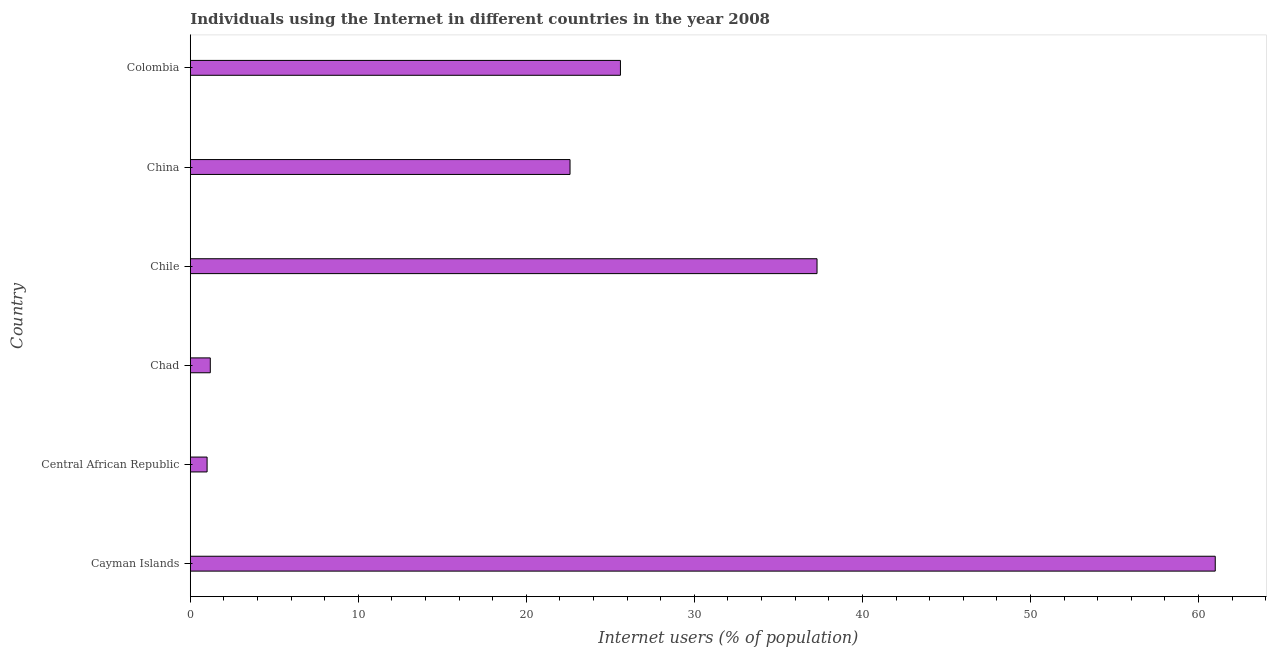Does the graph contain any zero values?
Keep it short and to the point. No. What is the title of the graph?
Ensure brevity in your answer.  Individuals using the Internet in different countries in the year 2008. What is the label or title of the X-axis?
Give a very brief answer. Internet users (% of population). In which country was the number of internet users maximum?
Provide a short and direct response. Cayman Islands. In which country was the number of internet users minimum?
Provide a short and direct response. Central African Republic. What is the sum of the number of internet users?
Your answer should be very brief. 148.69. What is the difference between the number of internet users in Chad and Chile?
Your answer should be compact. -36.11. What is the average number of internet users per country?
Your response must be concise. 24.78. What is the median number of internet users?
Your response must be concise. 24.1. In how many countries, is the number of internet users greater than 56 %?
Provide a succinct answer. 1. What is the ratio of the number of internet users in China to that in Colombia?
Your response must be concise. 0.88. Is the difference between the number of internet users in Central African Republic and China greater than the difference between any two countries?
Provide a short and direct response. No. What is the difference between the highest and the second highest number of internet users?
Keep it short and to the point. 23.7. Is the sum of the number of internet users in China and Colombia greater than the maximum number of internet users across all countries?
Your answer should be compact. No. What is the difference between the highest and the lowest number of internet users?
Give a very brief answer. 60. In how many countries, is the number of internet users greater than the average number of internet users taken over all countries?
Your answer should be very brief. 3. How many bars are there?
Keep it short and to the point. 6. Are all the bars in the graph horizontal?
Provide a short and direct response. Yes. How many countries are there in the graph?
Provide a succinct answer. 6. What is the difference between two consecutive major ticks on the X-axis?
Offer a very short reply. 10. What is the Internet users (% of population) of Central African Republic?
Your answer should be very brief. 1. What is the Internet users (% of population) in Chad?
Provide a succinct answer. 1.19. What is the Internet users (% of population) in Chile?
Give a very brief answer. 37.3. What is the Internet users (% of population) in China?
Your answer should be very brief. 22.6. What is the Internet users (% of population) of Colombia?
Ensure brevity in your answer.  25.6. What is the difference between the Internet users (% of population) in Cayman Islands and Chad?
Offer a very short reply. 59.81. What is the difference between the Internet users (% of population) in Cayman Islands and Chile?
Offer a terse response. 23.7. What is the difference between the Internet users (% of population) in Cayman Islands and China?
Offer a very short reply. 38.4. What is the difference between the Internet users (% of population) in Cayman Islands and Colombia?
Ensure brevity in your answer.  35.4. What is the difference between the Internet users (% of population) in Central African Republic and Chad?
Provide a succinct answer. -0.19. What is the difference between the Internet users (% of population) in Central African Republic and Chile?
Your answer should be very brief. -36.3. What is the difference between the Internet users (% of population) in Central African Republic and China?
Provide a succinct answer. -21.6. What is the difference between the Internet users (% of population) in Central African Republic and Colombia?
Keep it short and to the point. -24.6. What is the difference between the Internet users (% of population) in Chad and Chile?
Offer a terse response. -36.11. What is the difference between the Internet users (% of population) in Chad and China?
Offer a terse response. -21.41. What is the difference between the Internet users (% of population) in Chad and Colombia?
Keep it short and to the point. -24.41. What is the difference between the Internet users (% of population) in Chile and Colombia?
Make the answer very short. 11.7. What is the difference between the Internet users (% of population) in China and Colombia?
Ensure brevity in your answer.  -3. What is the ratio of the Internet users (% of population) in Cayman Islands to that in Chad?
Your answer should be very brief. 51.26. What is the ratio of the Internet users (% of population) in Cayman Islands to that in Chile?
Your response must be concise. 1.64. What is the ratio of the Internet users (% of population) in Cayman Islands to that in China?
Keep it short and to the point. 2.7. What is the ratio of the Internet users (% of population) in Cayman Islands to that in Colombia?
Provide a short and direct response. 2.38. What is the ratio of the Internet users (% of population) in Central African Republic to that in Chad?
Ensure brevity in your answer.  0.84. What is the ratio of the Internet users (% of population) in Central African Republic to that in Chile?
Your answer should be very brief. 0.03. What is the ratio of the Internet users (% of population) in Central African Republic to that in China?
Your answer should be very brief. 0.04. What is the ratio of the Internet users (% of population) in Central African Republic to that in Colombia?
Your answer should be very brief. 0.04. What is the ratio of the Internet users (% of population) in Chad to that in Chile?
Offer a terse response. 0.03. What is the ratio of the Internet users (% of population) in Chad to that in China?
Ensure brevity in your answer.  0.05. What is the ratio of the Internet users (% of population) in Chad to that in Colombia?
Keep it short and to the point. 0.05. What is the ratio of the Internet users (% of population) in Chile to that in China?
Your response must be concise. 1.65. What is the ratio of the Internet users (% of population) in Chile to that in Colombia?
Keep it short and to the point. 1.46. What is the ratio of the Internet users (% of population) in China to that in Colombia?
Offer a terse response. 0.88. 